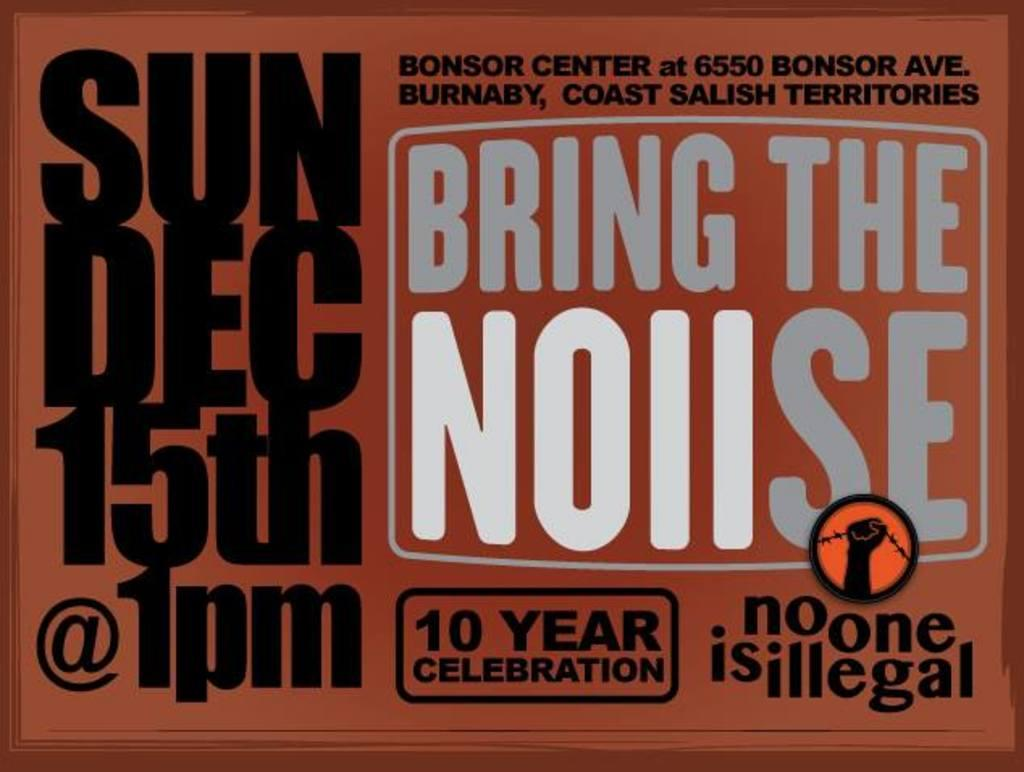<image>
Give a short and clear explanation of the subsequent image. a big sign ad that says bring the noise 10 year celbration 